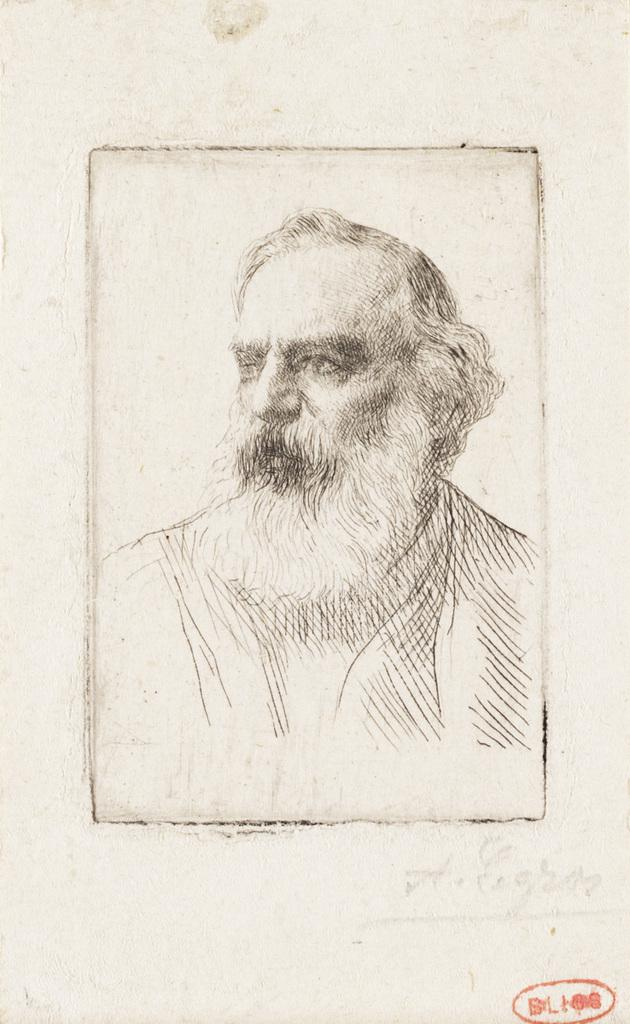What is the main subject of the image? The main subject of the image is a sketch of a man. What can be said about the color scheme of the image? The image is black and white in color. Is there any text or writing in the image? Yes, there is red writing in the bottom right corner of the image. What grade did the man receive on his mother's oil painting in the image? There is no mention of a mother, oil painting, or grade in the image. 